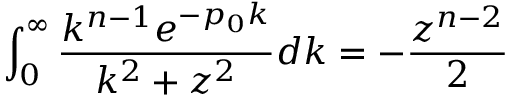<formula> <loc_0><loc_0><loc_500><loc_500>\int _ { 0 } ^ { \infty } \frac { k ^ { n - 1 } e ^ { - p _ { 0 } k } } { k ^ { 2 } + z ^ { 2 } } d k = - \frac { z ^ { n - 2 } } { 2 }</formula> 